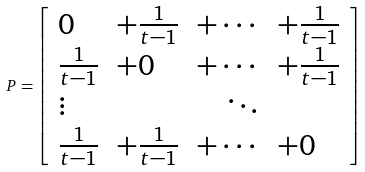<formula> <loc_0><loc_0><loc_500><loc_500>P = \left [ \begin{array} { l l l l } 0 & + \frac { 1 } { t - 1 } & + \cdots & + \frac { 1 } { t - 1 } \\ \frac { 1 } { t - 1 } & + 0 & + \cdots & + \frac { 1 } { t - 1 } \\ \vdots & & \quad \ddots & \\ \frac { 1 } { t - 1 } & + \frac { 1 } { t - 1 } & + \cdots & + 0 \end{array} \right ]</formula> 